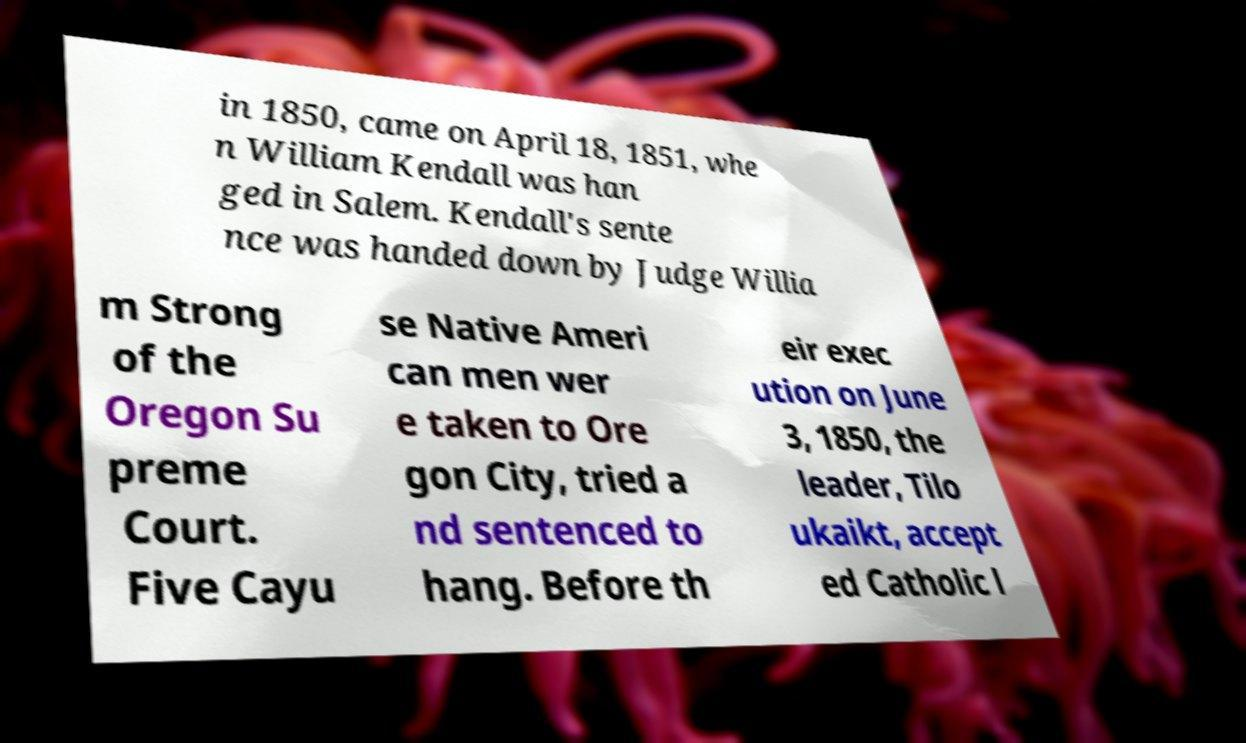Please identify and transcribe the text found in this image. in 1850, came on April 18, 1851, whe n William Kendall was han ged in Salem. Kendall's sente nce was handed down by Judge Willia m Strong of the Oregon Su preme Court. Five Cayu se Native Ameri can men wer e taken to Ore gon City, tried a nd sentenced to hang. Before th eir exec ution on June 3, 1850, the leader, Tilo ukaikt, accept ed Catholic l 